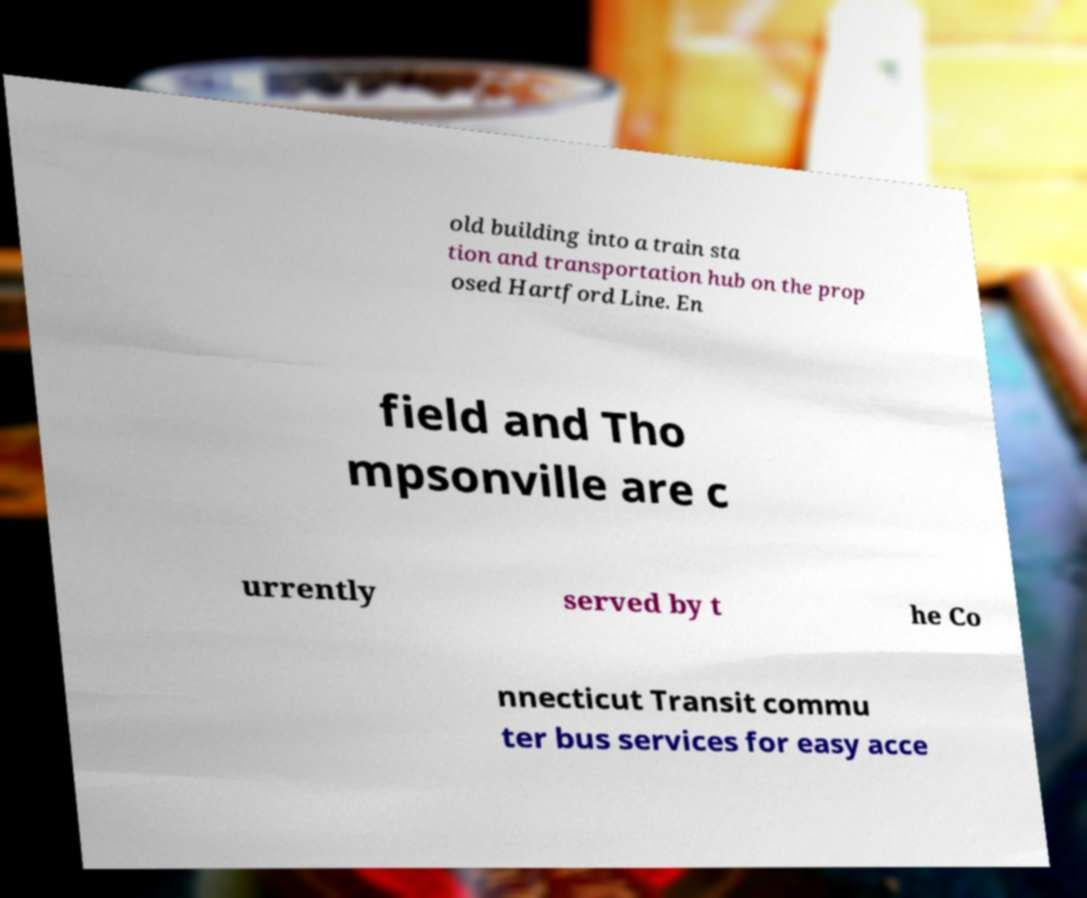Could you extract and type out the text from this image? old building into a train sta tion and transportation hub on the prop osed Hartford Line. En field and Tho mpsonville are c urrently served by t he Co nnecticut Transit commu ter bus services for easy acce 